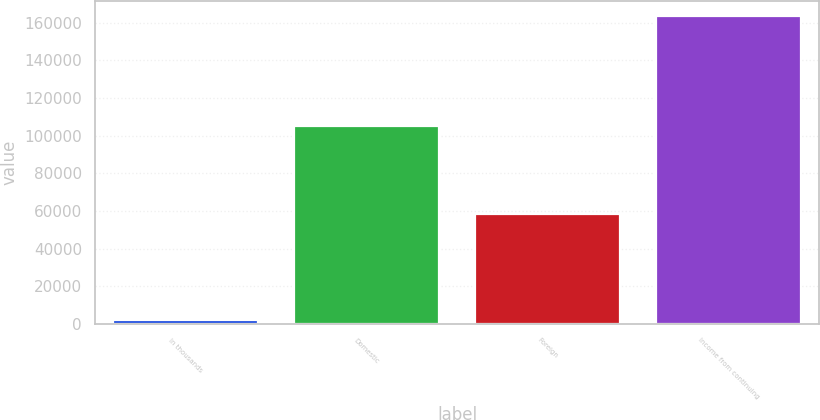<chart> <loc_0><loc_0><loc_500><loc_500><bar_chart><fcel>In thousands<fcel>Domestic<fcel>Foreign<fcel>Income from continuing<nl><fcel>2009<fcel>105122<fcel>58237<fcel>163359<nl></chart> 